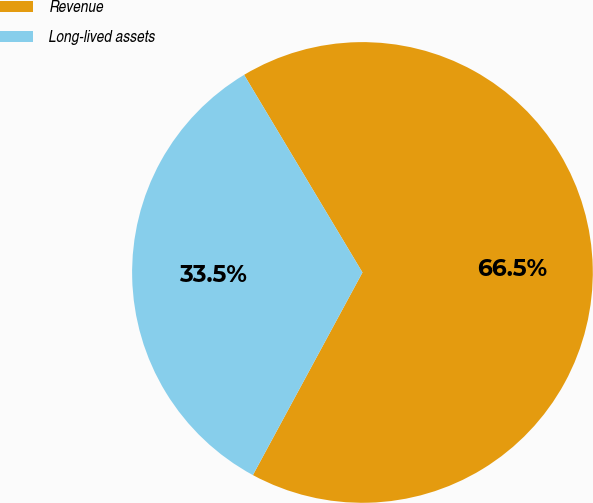Convert chart to OTSL. <chart><loc_0><loc_0><loc_500><loc_500><pie_chart><fcel>Revenue<fcel>Long-lived assets<nl><fcel>66.48%<fcel>33.52%<nl></chart> 